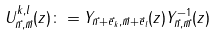<formula> <loc_0><loc_0><loc_500><loc_500>U _ { \vec { n } , \vec { m } } ^ { k , l } ( z ) \colon = Y _ { \vec { n } + \vec { e } _ { k } , \vec { m } + \vec { e } _ { l } } ( z ) Y _ { \vec { n } , \vec { m } } ^ { - 1 } ( z )</formula> 